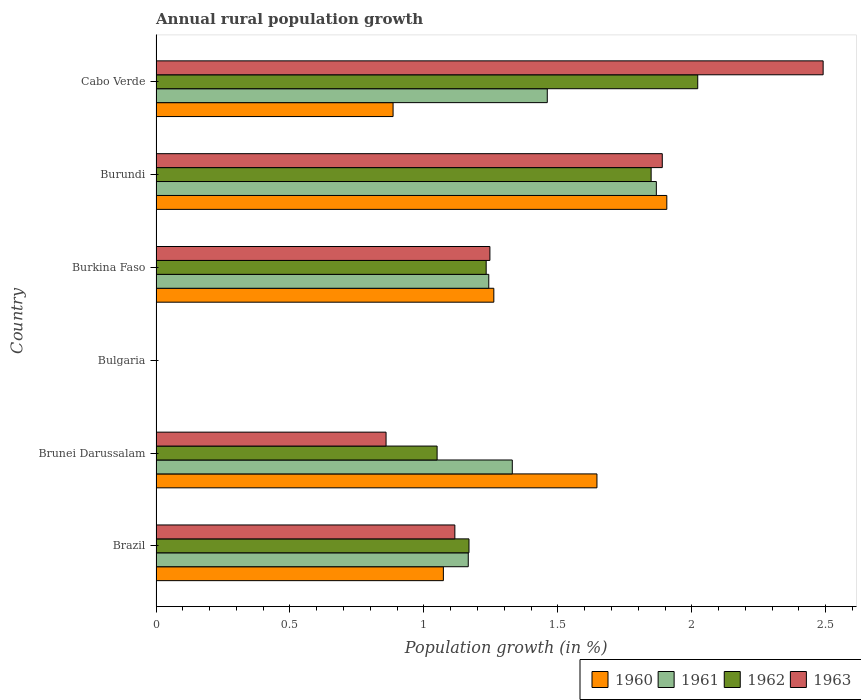How many bars are there on the 1st tick from the top?
Ensure brevity in your answer.  4. How many bars are there on the 5th tick from the bottom?
Your answer should be compact. 4. What is the label of the 1st group of bars from the top?
Give a very brief answer. Cabo Verde. What is the percentage of rural population growth in 1961 in Brazil?
Your response must be concise. 1.17. Across all countries, what is the maximum percentage of rural population growth in 1962?
Your answer should be compact. 2.02. Across all countries, what is the minimum percentage of rural population growth in 1961?
Keep it short and to the point. 0. In which country was the percentage of rural population growth in 1961 maximum?
Make the answer very short. Burundi. What is the total percentage of rural population growth in 1961 in the graph?
Give a very brief answer. 7.07. What is the difference between the percentage of rural population growth in 1962 in Brunei Darussalam and that in Burkina Faso?
Give a very brief answer. -0.18. What is the difference between the percentage of rural population growth in 1961 in Burkina Faso and the percentage of rural population growth in 1962 in Bulgaria?
Offer a terse response. 1.24. What is the average percentage of rural population growth in 1963 per country?
Offer a terse response. 1.27. What is the difference between the percentage of rural population growth in 1963 and percentage of rural population growth in 1961 in Burundi?
Your answer should be compact. 0.02. In how many countries, is the percentage of rural population growth in 1962 greater than 1.6 %?
Your answer should be compact. 2. What is the ratio of the percentage of rural population growth in 1963 in Brazil to that in Burkina Faso?
Your response must be concise. 0.9. Is the percentage of rural population growth in 1961 in Burundi less than that in Cabo Verde?
Your answer should be very brief. No. Is the difference between the percentage of rural population growth in 1963 in Burkina Faso and Cabo Verde greater than the difference between the percentage of rural population growth in 1961 in Burkina Faso and Cabo Verde?
Keep it short and to the point. No. What is the difference between the highest and the second highest percentage of rural population growth in 1960?
Your answer should be compact. 0.26. What is the difference between the highest and the lowest percentage of rural population growth in 1962?
Offer a very short reply. 2.02. In how many countries, is the percentage of rural population growth in 1961 greater than the average percentage of rural population growth in 1961 taken over all countries?
Your response must be concise. 4. Is it the case that in every country, the sum of the percentage of rural population growth in 1963 and percentage of rural population growth in 1960 is greater than the percentage of rural population growth in 1961?
Provide a short and direct response. No. How many bars are there?
Give a very brief answer. 20. Are all the bars in the graph horizontal?
Your answer should be compact. Yes. How many legend labels are there?
Make the answer very short. 4. What is the title of the graph?
Keep it short and to the point. Annual rural population growth. Does "1974" appear as one of the legend labels in the graph?
Your answer should be compact. No. What is the label or title of the X-axis?
Keep it short and to the point. Population growth (in %). What is the label or title of the Y-axis?
Offer a terse response. Country. What is the Population growth (in %) in 1960 in Brazil?
Your answer should be compact. 1.07. What is the Population growth (in %) in 1961 in Brazil?
Your response must be concise. 1.17. What is the Population growth (in %) of 1962 in Brazil?
Give a very brief answer. 1.17. What is the Population growth (in %) in 1963 in Brazil?
Offer a very short reply. 1.12. What is the Population growth (in %) of 1960 in Brunei Darussalam?
Provide a short and direct response. 1.65. What is the Population growth (in %) of 1961 in Brunei Darussalam?
Offer a terse response. 1.33. What is the Population growth (in %) of 1962 in Brunei Darussalam?
Provide a succinct answer. 1.05. What is the Population growth (in %) in 1963 in Brunei Darussalam?
Your answer should be compact. 0.86. What is the Population growth (in %) of 1960 in Burkina Faso?
Provide a succinct answer. 1.26. What is the Population growth (in %) in 1961 in Burkina Faso?
Provide a short and direct response. 1.24. What is the Population growth (in %) in 1962 in Burkina Faso?
Your response must be concise. 1.23. What is the Population growth (in %) in 1963 in Burkina Faso?
Offer a terse response. 1.25. What is the Population growth (in %) in 1960 in Burundi?
Offer a very short reply. 1.91. What is the Population growth (in %) of 1961 in Burundi?
Provide a short and direct response. 1.87. What is the Population growth (in %) in 1962 in Burundi?
Provide a succinct answer. 1.85. What is the Population growth (in %) in 1963 in Burundi?
Keep it short and to the point. 1.89. What is the Population growth (in %) in 1960 in Cabo Verde?
Your answer should be very brief. 0.88. What is the Population growth (in %) in 1961 in Cabo Verde?
Offer a terse response. 1.46. What is the Population growth (in %) in 1962 in Cabo Verde?
Offer a terse response. 2.02. What is the Population growth (in %) in 1963 in Cabo Verde?
Provide a short and direct response. 2.49. Across all countries, what is the maximum Population growth (in %) of 1960?
Give a very brief answer. 1.91. Across all countries, what is the maximum Population growth (in %) of 1961?
Keep it short and to the point. 1.87. Across all countries, what is the maximum Population growth (in %) in 1962?
Offer a terse response. 2.02. Across all countries, what is the maximum Population growth (in %) of 1963?
Give a very brief answer. 2.49. Across all countries, what is the minimum Population growth (in %) of 1960?
Provide a succinct answer. 0. Across all countries, what is the minimum Population growth (in %) in 1962?
Give a very brief answer. 0. What is the total Population growth (in %) of 1960 in the graph?
Offer a terse response. 6.77. What is the total Population growth (in %) in 1961 in the graph?
Ensure brevity in your answer.  7.07. What is the total Population growth (in %) of 1962 in the graph?
Your answer should be compact. 7.32. What is the total Population growth (in %) in 1963 in the graph?
Provide a short and direct response. 7.6. What is the difference between the Population growth (in %) in 1960 in Brazil and that in Brunei Darussalam?
Offer a very short reply. -0.57. What is the difference between the Population growth (in %) of 1961 in Brazil and that in Brunei Darussalam?
Keep it short and to the point. -0.16. What is the difference between the Population growth (in %) in 1962 in Brazil and that in Brunei Darussalam?
Provide a short and direct response. 0.12. What is the difference between the Population growth (in %) in 1963 in Brazil and that in Brunei Darussalam?
Your answer should be compact. 0.26. What is the difference between the Population growth (in %) in 1960 in Brazil and that in Burkina Faso?
Provide a short and direct response. -0.19. What is the difference between the Population growth (in %) of 1961 in Brazil and that in Burkina Faso?
Provide a short and direct response. -0.08. What is the difference between the Population growth (in %) in 1962 in Brazil and that in Burkina Faso?
Your response must be concise. -0.06. What is the difference between the Population growth (in %) in 1963 in Brazil and that in Burkina Faso?
Offer a very short reply. -0.13. What is the difference between the Population growth (in %) in 1960 in Brazil and that in Burundi?
Your answer should be very brief. -0.83. What is the difference between the Population growth (in %) of 1961 in Brazil and that in Burundi?
Ensure brevity in your answer.  -0.7. What is the difference between the Population growth (in %) in 1962 in Brazil and that in Burundi?
Your response must be concise. -0.68. What is the difference between the Population growth (in %) of 1963 in Brazil and that in Burundi?
Keep it short and to the point. -0.77. What is the difference between the Population growth (in %) in 1960 in Brazil and that in Cabo Verde?
Provide a short and direct response. 0.19. What is the difference between the Population growth (in %) of 1961 in Brazil and that in Cabo Verde?
Keep it short and to the point. -0.29. What is the difference between the Population growth (in %) of 1962 in Brazil and that in Cabo Verde?
Offer a terse response. -0.85. What is the difference between the Population growth (in %) of 1963 in Brazil and that in Cabo Verde?
Make the answer very short. -1.37. What is the difference between the Population growth (in %) in 1960 in Brunei Darussalam and that in Burkina Faso?
Provide a succinct answer. 0.38. What is the difference between the Population growth (in %) in 1961 in Brunei Darussalam and that in Burkina Faso?
Offer a terse response. 0.09. What is the difference between the Population growth (in %) in 1962 in Brunei Darussalam and that in Burkina Faso?
Your response must be concise. -0.18. What is the difference between the Population growth (in %) of 1963 in Brunei Darussalam and that in Burkina Faso?
Make the answer very short. -0.39. What is the difference between the Population growth (in %) in 1960 in Brunei Darussalam and that in Burundi?
Keep it short and to the point. -0.26. What is the difference between the Population growth (in %) in 1961 in Brunei Darussalam and that in Burundi?
Offer a very short reply. -0.54. What is the difference between the Population growth (in %) of 1962 in Brunei Darussalam and that in Burundi?
Offer a very short reply. -0.8. What is the difference between the Population growth (in %) in 1963 in Brunei Darussalam and that in Burundi?
Keep it short and to the point. -1.03. What is the difference between the Population growth (in %) in 1960 in Brunei Darussalam and that in Cabo Verde?
Ensure brevity in your answer.  0.76. What is the difference between the Population growth (in %) of 1961 in Brunei Darussalam and that in Cabo Verde?
Keep it short and to the point. -0.13. What is the difference between the Population growth (in %) of 1962 in Brunei Darussalam and that in Cabo Verde?
Ensure brevity in your answer.  -0.97. What is the difference between the Population growth (in %) in 1963 in Brunei Darussalam and that in Cabo Verde?
Ensure brevity in your answer.  -1.63. What is the difference between the Population growth (in %) of 1960 in Burkina Faso and that in Burundi?
Ensure brevity in your answer.  -0.65. What is the difference between the Population growth (in %) of 1961 in Burkina Faso and that in Burundi?
Offer a very short reply. -0.63. What is the difference between the Population growth (in %) in 1962 in Burkina Faso and that in Burundi?
Provide a succinct answer. -0.62. What is the difference between the Population growth (in %) in 1963 in Burkina Faso and that in Burundi?
Your response must be concise. -0.64. What is the difference between the Population growth (in %) of 1960 in Burkina Faso and that in Cabo Verde?
Offer a terse response. 0.38. What is the difference between the Population growth (in %) of 1961 in Burkina Faso and that in Cabo Verde?
Your answer should be compact. -0.22. What is the difference between the Population growth (in %) of 1962 in Burkina Faso and that in Cabo Verde?
Your answer should be very brief. -0.79. What is the difference between the Population growth (in %) of 1963 in Burkina Faso and that in Cabo Verde?
Ensure brevity in your answer.  -1.24. What is the difference between the Population growth (in %) in 1960 in Burundi and that in Cabo Verde?
Make the answer very short. 1.02. What is the difference between the Population growth (in %) in 1961 in Burundi and that in Cabo Verde?
Your answer should be very brief. 0.41. What is the difference between the Population growth (in %) in 1962 in Burundi and that in Cabo Verde?
Make the answer very short. -0.17. What is the difference between the Population growth (in %) of 1963 in Burundi and that in Cabo Verde?
Offer a terse response. -0.6. What is the difference between the Population growth (in %) of 1960 in Brazil and the Population growth (in %) of 1961 in Brunei Darussalam?
Give a very brief answer. -0.26. What is the difference between the Population growth (in %) of 1960 in Brazil and the Population growth (in %) of 1962 in Brunei Darussalam?
Offer a terse response. 0.02. What is the difference between the Population growth (in %) in 1960 in Brazil and the Population growth (in %) in 1963 in Brunei Darussalam?
Provide a succinct answer. 0.21. What is the difference between the Population growth (in %) in 1961 in Brazil and the Population growth (in %) in 1962 in Brunei Darussalam?
Offer a very short reply. 0.12. What is the difference between the Population growth (in %) in 1961 in Brazil and the Population growth (in %) in 1963 in Brunei Darussalam?
Make the answer very short. 0.31. What is the difference between the Population growth (in %) of 1962 in Brazil and the Population growth (in %) of 1963 in Brunei Darussalam?
Your answer should be very brief. 0.31. What is the difference between the Population growth (in %) in 1960 in Brazil and the Population growth (in %) in 1961 in Burkina Faso?
Your answer should be very brief. -0.17. What is the difference between the Population growth (in %) of 1960 in Brazil and the Population growth (in %) of 1962 in Burkina Faso?
Your answer should be very brief. -0.16. What is the difference between the Population growth (in %) of 1960 in Brazil and the Population growth (in %) of 1963 in Burkina Faso?
Provide a succinct answer. -0.17. What is the difference between the Population growth (in %) of 1961 in Brazil and the Population growth (in %) of 1962 in Burkina Faso?
Offer a terse response. -0.07. What is the difference between the Population growth (in %) of 1961 in Brazil and the Population growth (in %) of 1963 in Burkina Faso?
Offer a terse response. -0.08. What is the difference between the Population growth (in %) in 1962 in Brazil and the Population growth (in %) in 1963 in Burkina Faso?
Provide a succinct answer. -0.08. What is the difference between the Population growth (in %) of 1960 in Brazil and the Population growth (in %) of 1961 in Burundi?
Keep it short and to the point. -0.8. What is the difference between the Population growth (in %) of 1960 in Brazil and the Population growth (in %) of 1962 in Burundi?
Offer a very short reply. -0.78. What is the difference between the Population growth (in %) in 1960 in Brazil and the Population growth (in %) in 1963 in Burundi?
Offer a very short reply. -0.82. What is the difference between the Population growth (in %) in 1961 in Brazil and the Population growth (in %) in 1962 in Burundi?
Make the answer very short. -0.68. What is the difference between the Population growth (in %) in 1961 in Brazil and the Population growth (in %) in 1963 in Burundi?
Provide a short and direct response. -0.72. What is the difference between the Population growth (in %) in 1962 in Brazil and the Population growth (in %) in 1963 in Burundi?
Keep it short and to the point. -0.72. What is the difference between the Population growth (in %) of 1960 in Brazil and the Population growth (in %) of 1961 in Cabo Verde?
Provide a succinct answer. -0.39. What is the difference between the Population growth (in %) of 1960 in Brazil and the Population growth (in %) of 1962 in Cabo Verde?
Provide a short and direct response. -0.95. What is the difference between the Population growth (in %) in 1960 in Brazil and the Population growth (in %) in 1963 in Cabo Verde?
Keep it short and to the point. -1.42. What is the difference between the Population growth (in %) in 1961 in Brazil and the Population growth (in %) in 1962 in Cabo Verde?
Make the answer very short. -0.86. What is the difference between the Population growth (in %) in 1961 in Brazil and the Population growth (in %) in 1963 in Cabo Verde?
Provide a short and direct response. -1.32. What is the difference between the Population growth (in %) of 1962 in Brazil and the Population growth (in %) of 1963 in Cabo Verde?
Your answer should be very brief. -1.32. What is the difference between the Population growth (in %) in 1960 in Brunei Darussalam and the Population growth (in %) in 1961 in Burkina Faso?
Offer a very short reply. 0.4. What is the difference between the Population growth (in %) of 1960 in Brunei Darussalam and the Population growth (in %) of 1962 in Burkina Faso?
Offer a terse response. 0.41. What is the difference between the Population growth (in %) of 1960 in Brunei Darussalam and the Population growth (in %) of 1963 in Burkina Faso?
Your answer should be compact. 0.4. What is the difference between the Population growth (in %) of 1961 in Brunei Darussalam and the Population growth (in %) of 1962 in Burkina Faso?
Ensure brevity in your answer.  0.1. What is the difference between the Population growth (in %) of 1961 in Brunei Darussalam and the Population growth (in %) of 1963 in Burkina Faso?
Provide a short and direct response. 0.08. What is the difference between the Population growth (in %) in 1962 in Brunei Darussalam and the Population growth (in %) in 1963 in Burkina Faso?
Your answer should be very brief. -0.2. What is the difference between the Population growth (in %) of 1960 in Brunei Darussalam and the Population growth (in %) of 1961 in Burundi?
Your answer should be very brief. -0.22. What is the difference between the Population growth (in %) in 1960 in Brunei Darussalam and the Population growth (in %) in 1962 in Burundi?
Your response must be concise. -0.2. What is the difference between the Population growth (in %) in 1960 in Brunei Darussalam and the Population growth (in %) in 1963 in Burundi?
Ensure brevity in your answer.  -0.24. What is the difference between the Population growth (in %) of 1961 in Brunei Darussalam and the Population growth (in %) of 1962 in Burundi?
Keep it short and to the point. -0.52. What is the difference between the Population growth (in %) in 1961 in Brunei Darussalam and the Population growth (in %) in 1963 in Burundi?
Offer a terse response. -0.56. What is the difference between the Population growth (in %) of 1962 in Brunei Darussalam and the Population growth (in %) of 1963 in Burundi?
Ensure brevity in your answer.  -0.84. What is the difference between the Population growth (in %) of 1960 in Brunei Darussalam and the Population growth (in %) of 1961 in Cabo Verde?
Give a very brief answer. 0.19. What is the difference between the Population growth (in %) in 1960 in Brunei Darussalam and the Population growth (in %) in 1962 in Cabo Verde?
Make the answer very short. -0.38. What is the difference between the Population growth (in %) of 1960 in Brunei Darussalam and the Population growth (in %) of 1963 in Cabo Verde?
Your answer should be very brief. -0.84. What is the difference between the Population growth (in %) in 1961 in Brunei Darussalam and the Population growth (in %) in 1962 in Cabo Verde?
Offer a very short reply. -0.69. What is the difference between the Population growth (in %) in 1961 in Brunei Darussalam and the Population growth (in %) in 1963 in Cabo Verde?
Your answer should be compact. -1.16. What is the difference between the Population growth (in %) in 1962 in Brunei Darussalam and the Population growth (in %) in 1963 in Cabo Verde?
Offer a terse response. -1.44. What is the difference between the Population growth (in %) in 1960 in Burkina Faso and the Population growth (in %) in 1961 in Burundi?
Your response must be concise. -0.61. What is the difference between the Population growth (in %) of 1960 in Burkina Faso and the Population growth (in %) of 1962 in Burundi?
Your answer should be very brief. -0.59. What is the difference between the Population growth (in %) in 1960 in Burkina Faso and the Population growth (in %) in 1963 in Burundi?
Provide a succinct answer. -0.63. What is the difference between the Population growth (in %) in 1961 in Burkina Faso and the Population growth (in %) in 1962 in Burundi?
Ensure brevity in your answer.  -0.61. What is the difference between the Population growth (in %) in 1961 in Burkina Faso and the Population growth (in %) in 1963 in Burundi?
Provide a succinct answer. -0.65. What is the difference between the Population growth (in %) of 1962 in Burkina Faso and the Population growth (in %) of 1963 in Burundi?
Your answer should be compact. -0.66. What is the difference between the Population growth (in %) of 1960 in Burkina Faso and the Population growth (in %) of 1961 in Cabo Verde?
Your answer should be compact. -0.2. What is the difference between the Population growth (in %) of 1960 in Burkina Faso and the Population growth (in %) of 1962 in Cabo Verde?
Your answer should be very brief. -0.76. What is the difference between the Population growth (in %) of 1960 in Burkina Faso and the Population growth (in %) of 1963 in Cabo Verde?
Provide a short and direct response. -1.23. What is the difference between the Population growth (in %) in 1961 in Burkina Faso and the Population growth (in %) in 1962 in Cabo Verde?
Offer a terse response. -0.78. What is the difference between the Population growth (in %) in 1961 in Burkina Faso and the Population growth (in %) in 1963 in Cabo Verde?
Make the answer very short. -1.25. What is the difference between the Population growth (in %) of 1962 in Burkina Faso and the Population growth (in %) of 1963 in Cabo Verde?
Your response must be concise. -1.26. What is the difference between the Population growth (in %) in 1960 in Burundi and the Population growth (in %) in 1961 in Cabo Verde?
Offer a terse response. 0.45. What is the difference between the Population growth (in %) in 1960 in Burundi and the Population growth (in %) in 1962 in Cabo Verde?
Offer a terse response. -0.12. What is the difference between the Population growth (in %) of 1960 in Burundi and the Population growth (in %) of 1963 in Cabo Verde?
Your answer should be compact. -0.58. What is the difference between the Population growth (in %) in 1961 in Burundi and the Population growth (in %) in 1962 in Cabo Verde?
Offer a very short reply. -0.15. What is the difference between the Population growth (in %) in 1961 in Burundi and the Population growth (in %) in 1963 in Cabo Verde?
Offer a terse response. -0.62. What is the difference between the Population growth (in %) of 1962 in Burundi and the Population growth (in %) of 1963 in Cabo Verde?
Keep it short and to the point. -0.64. What is the average Population growth (in %) in 1960 per country?
Provide a succinct answer. 1.13. What is the average Population growth (in %) in 1961 per country?
Ensure brevity in your answer.  1.18. What is the average Population growth (in %) in 1962 per country?
Your answer should be compact. 1.22. What is the average Population growth (in %) of 1963 per country?
Make the answer very short. 1.27. What is the difference between the Population growth (in %) of 1960 and Population growth (in %) of 1961 in Brazil?
Your answer should be compact. -0.09. What is the difference between the Population growth (in %) in 1960 and Population growth (in %) in 1962 in Brazil?
Give a very brief answer. -0.1. What is the difference between the Population growth (in %) of 1960 and Population growth (in %) of 1963 in Brazil?
Offer a very short reply. -0.04. What is the difference between the Population growth (in %) in 1961 and Population growth (in %) in 1962 in Brazil?
Your response must be concise. -0. What is the difference between the Population growth (in %) in 1962 and Population growth (in %) in 1963 in Brazil?
Your response must be concise. 0.05. What is the difference between the Population growth (in %) in 1960 and Population growth (in %) in 1961 in Brunei Darussalam?
Provide a succinct answer. 0.32. What is the difference between the Population growth (in %) in 1960 and Population growth (in %) in 1962 in Brunei Darussalam?
Your answer should be very brief. 0.6. What is the difference between the Population growth (in %) of 1960 and Population growth (in %) of 1963 in Brunei Darussalam?
Keep it short and to the point. 0.79. What is the difference between the Population growth (in %) of 1961 and Population growth (in %) of 1962 in Brunei Darussalam?
Provide a succinct answer. 0.28. What is the difference between the Population growth (in %) in 1961 and Population growth (in %) in 1963 in Brunei Darussalam?
Ensure brevity in your answer.  0.47. What is the difference between the Population growth (in %) in 1962 and Population growth (in %) in 1963 in Brunei Darussalam?
Make the answer very short. 0.19. What is the difference between the Population growth (in %) in 1960 and Population growth (in %) in 1961 in Burkina Faso?
Offer a very short reply. 0.02. What is the difference between the Population growth (in %) of 1960 and Population growth (in %) of 1962 in Burkina Faso?
Offer a terse response. 0.03. What is the difference between the Population growth (in %) in 1960 and Population growth (in %) in 1963 in Burkina Faso?
Offer a very short reply. 0.01. What is the difference between the Population growth (in %) of 1961 and Population growth (in %) of 1962 in Burkina Faso?
Ensure brevity in your answer.  0.01. What is the difference between the Population growth (in %) in 1961 and Population growth (in %) in 1963 in Burkina Faso?
Provide a short and direct response. -0. What is the difference between the Population growth (in %) of 1962 and Population growth (in %) of 1963 in Burkina Faso?
Provide a succinct answer. -0.01. What is the difference between the Population growth (in %) in 1960 and Population growth (in %) in 1961 in Burundi?
Your answer should be compact. 0.04. What is the difference between the Population growth (in %) of 1960 and Population growth (in %) of 1962 in Burundi?
Your answer should be compact. 0.06. What is the difference between the Population growth (in %) of 1960 and Population growth (in %) of 1963 in Burundi?
Your response must be concise. 0.02. What is the difference between the Population growth (in %) in 1961 and Population growth (in %) in 1962 in Burundi?
Keep it short and to the point. 0.02. What is the difference between the Population growth (in %) in 1961 and Population growth (in %) in 1963 in Burundi?
Keep it short and to the point. -0.02. What is the difference between the Population growth (in %) of 1962 and Population growth (in %) of 1963 in Burundi?
Your answer should be very brief. -0.04. What is the difference between the Population growth (in %) in 1960 and Population growth (in %) in 1961 in Cabo Verde?
Your answer should be compact. -0.58. What is the difference between the Population growth (in %) in 1960 and Population growth (in %) in 1962 in Cabo Verde?
Your answer should be very brief. -1.14. What is the difference between the Population growth (in %) of 1960 and Population growth (in %) of 1963 in Cabo Verde?
Ensure brevity in your answer.  -1.61. What is the difference between the Population growth (in %) of 1961 and Population growth (in %) of 1962 in Cabo Verde?
Your answer should be very brief. -0.56. What is the difference between the Population growth (in %) in 1961 and Population growth (in %) in 1963 in Cabo Verde?
Your answer should be very brief. -1.03. What is the difference between the Population growth (in %) in 1962 and Population growth (in %) in 1963 in Cabo Verde?
Your answer should be very brief. -0.47. What is the ratio of the Population growth (in %) in 1960 in Brazil to that in Brunei Darussalam?
Provide a short and direct response. 0.65. What is the ratio of the Population growth (in %) of 1961 in Brazil to that in Brunei Darussalam?
Your answer should be compact. 0.88. What is the ratio of the Population growth (in %) in 1962 in Brazil to that in Brunei Darussalam?
Provide a succinct answer. 1.11. What is the ratio of the Population growth (in %) in 1963 in Brazil to that in Brunei Darussalam?
Your answer should be compact. 1.3. What is the ratio of the Population growth (in %) of 1960 in Brazil to that in Burkina Faso?
Provide a short and direct response. 0.85. What is the ratio of the Population growth (in %) of 1961 in Brazil to that in Burkina Faso?
Give a very brief answer. 0.94. What is the ratio of the Population growth (in %) of 1962 in Brazil to that in Burkina Faso?
Offer a terse response. 0.95. What is the ratio of the Population growth (in %) of 1963 in Brazil to that in Burkina Faso?
Offer a very short reply. 0.9. What is the ratio of the Population growth (in %) of 1960 in Brazil to that in Burundi?
Ensure brevity in your answer.  0.56. What is the ratio of the Population growth (in %) of 1961 in Brazil to that in Burundi?
Provide a short and direct response. 0.62. What is the ratio of the Population growth (in %) in 1962 in Brazil to that in Burundi?
Provide a short and direct response. 0.63. What is the ratio of the Population growth (in %) in 1963 in Brazil to that in Burundi?
Your response must be concise. 0.59. What is the ratio of the Population growth (in %) of 1960 in Brazil to that in Cabo Verde?
Offer a terse response. 1.21. What is the ratio of the Population growth (in %) in 1961 in Brazil to that in Cabo Verde?
Your response must be concise. 0.8. What is the ratio of the Population growth (in %) of 1962 in Brazil to that in Cabo Verde?
Your answer should be compact. 0.58. What is the ratio of the Population growth (in %) of 1963 in Brazil to that in Cabo Verde?
Make the answer very short. 0.45. What is the ratio of the Population growth (in %) in 1960 in Brunei Darussalam to that in Burkina Faso?
Provide a succinct answer. 1.31. What is the ratio of the Population growth (in %) in 1961 in Brunei Darussalam to that in Burkina Faso?
Your response must be concise. 1.07. What is the ratio of the Population growth (in %) in 1962 in Brunei Darussalam to that in Burkina Faso?
Your answer should be very brief. 0.85. What is the ratio of the Population growth (in %) in 1963 in Brunei Darussalam to that in Burkina Faso?
Offer a terse response. 0.69. What is the ratio of the Population growth (in %) of 1960 in Brunei Darussalam to that in Burundi?
Provide a short and direct response. 0.86. What is the ratio of the Population growth (in %) of 1961 in Brunei Darussalam to that in Burundi?
Your answer should be very brief. 0.71. What is the ratio of the Population growth (in %) of 1962 in Brunei Darussalam to that in Burundi?
Provide a short and direct response. 0.57. What is the ratio of the Population growth (in %) of 1963 in Brunei Darussalam to that in Burundi?
Make the answer very short. 0.45. What is the ratio of the Population growth (in %) of 1960 in Brunei Darussalam to that in Cabo Verde?
Keep it short and to the point. 1.86. What is the ratio of the Population growth (in %) of 1961 in Brunei Darussalam to that in Cabo Verde?
Provide a short and direct response. 0.91. What is the ratio of the Population growth (in %) in 1962 in Brunei Darussalam to that in Cabo Verde?
Keep it short and to the point. 0.52. What is the ratio of the Population growth (in %) of 1963 in Brunei Darussalam to that in Cabo Verde?
Ensure brevity in your answer.  0.34. What is the ratio of the Population growth (in %) in 1960 in Burkina Faso to that in Burundi?
Give a very brief answer. 0.66. What is the ratio of the Population growth (in %) in 1961 in Burkina Faso to that in Burundi?
Your response must be concise. 0.67. What is the ratio of the Population growth (in %) of 1962 in Burkina Faso to that in Burundi?
Give a very brief answer. 0.67. What is the ratio of the Population growth (in %) in 1963 in Burkina Faso to that in Burundi?
Give a very brief answer. 0.66. What is the ratio of the Population growth (in %) in 1960 in Burkina Faso to that in Cabo Verde?
Ensure brevity in your answer.  1.43. What is the ratio of the Population growth (in %) of 1961 in Burkina Faso to that in Cabo Verde?
Your answer should be very brief. 0.85. What is the ratio of the Population growth (in %) of 1962 in Burkina Faso to that in Cabo Verde?
Provide a succinct answer. 0.61. What is the ratio of the Population growth (in %) in 1963 in Burkina Faso to that in Cabo Verde?
Your answer should be very brief. 0.5. What is the ratio of the Population growth (in %) of 1960 in Burundi to that in Cabo Verde?
Keep it short and to the point. 2.15. What is the ratio of the Population growth (in %) of 1961 in Burundi to that in Cabo Verde?
Your answer should be compact. 1.28. What is the ratio of the Population growth (in %) of 1962 in Burundi to that in Cabo Verde?
Offer a very short reply. 0.91. What is the ratio of the Population growth (in %) in 1963 in Burundi to that in Cabo Verde?
Keep it short and to the point. 0.76. What is the difference between the highest and the second highest Population growth (in %) of 1960?
Make the answer very short. 0.26. What is the difference between the highest and the second highest Population growth (in %) of 1961?
Give a very brief answer. 0.41. What is the difference between the highest and the second highest Population growth (in %) in 1962?
Provide a short and direct response. 0.17. What is the difference between the highest and the second highest Population growth (in %) of 1963?
Offer a terse response. 0.6. What is the difference between the highest and the lowest Population growth (in %) in 1960?
Keep it short and to the point. 1.91. What is the difference between the highest and the lowest Population growth (in %) in 1961?
Offer a terse response. 1.87. What is the difference between the highest and the lowest Population growth (in %) in 1962?
Offer a terse response. 2.02. What is the difference between the highest and the lowest Population growth (in %) in 1963?
Keep it short and to the point. 2.49. 